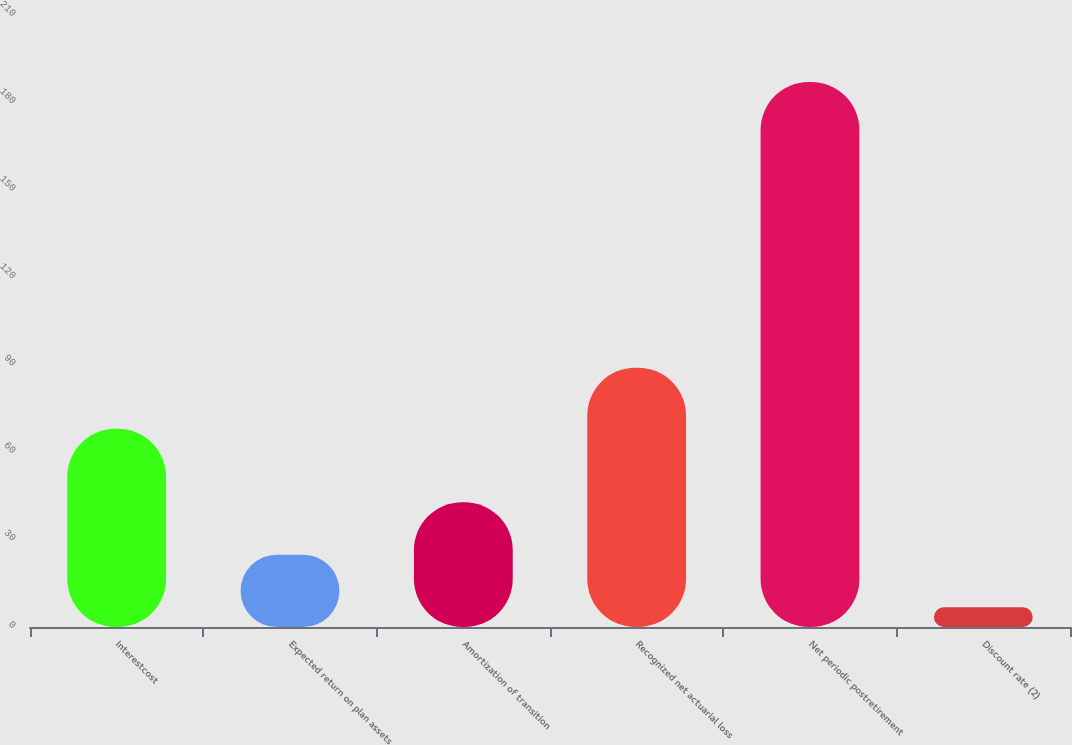Convert chart to OTSL. <chart><loc_0><loc_0><loc_500><loc_500><bar_chart><fcel>Interestcost<fcel>Expected return on plan assets<fcel>Amortization of transition<fcel>Recognized net actuarial loss<fcel>Net periodic postretirement<fcel>Discount rate (2)<nl><fcel>68<fcel>24.78<fcel>42.81<fcel>89<fcel>187<fcel>6.75<nl></chart> 